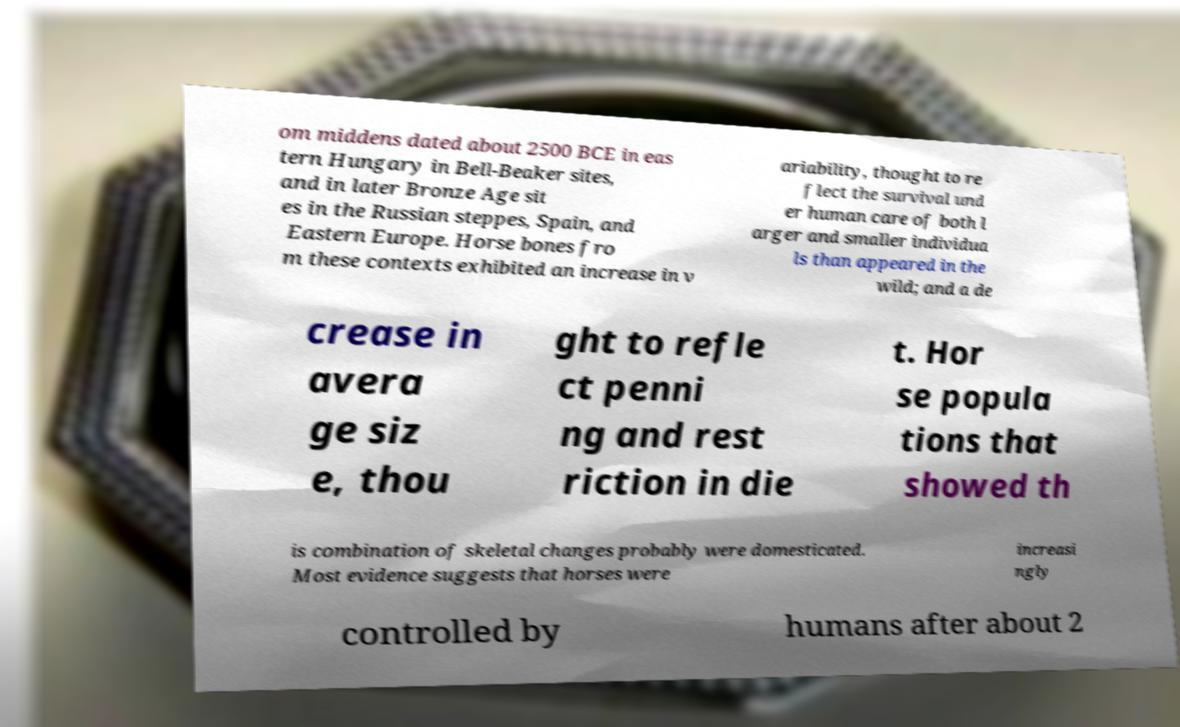Please identify and transcribe the text found in this image. om middens dated about 2500 BCE in eas tern Hungary in Bell-Beaker sites, and in later Bronze Age sit es in the Russian steppes, Spain, and Eastern Europe. Horse bones fro m these contexts exhibited an increase in v ariability, thought to re flect the survival und er human care of both l arger and smaller individua ls than appeared in the wild; and a de crease in avera ge siz e, thou ght to refle ct penni ng and rest riction in die t. Hor se popula tions that showed th is combination of skeletal changes probably were domesticated. Most evidence suggests that horses were increasi ngly controlled by humans after about 2 